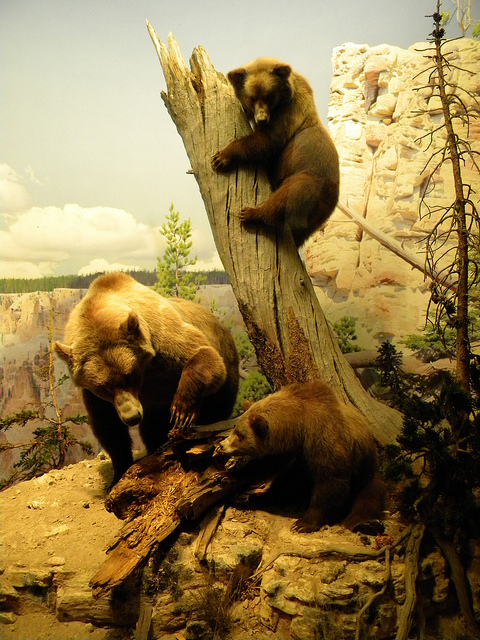<image>Is the bear white or yellow? I can't be certain. The bear could be white, yellow, or brown. Is the bear white or yellow? I am not sure if the bear is white or yellow. However, it can be seen brown. 